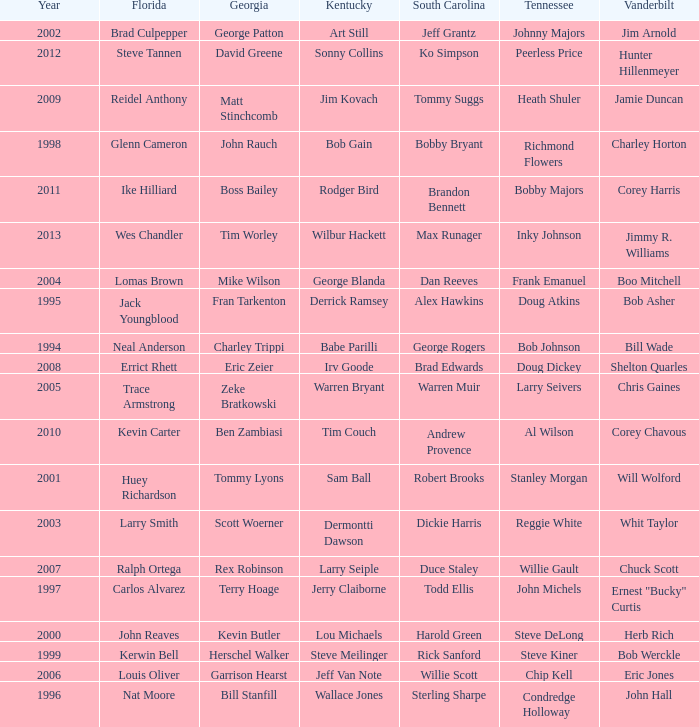What is the Tennessee that Georgia of kevin butler is in? Steve DeLong. 